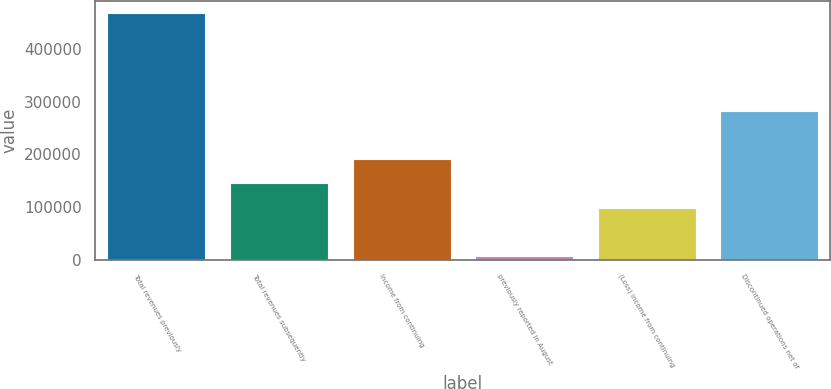Convert chart. <chart><loc_0><loc_0><loc_500><loc_500><bar_chart><fcel>Total revenues previously<fcel>Total revenues subsequently<fcel>Income from continuing<fcel>previously reported in August<fcel>(Loss) income from continuing<fcel>Discontinued operations net of<nl><fcel>467533<fcel>145329<fcel>191358<fcel>7241<fcel>99299.4<fcel>283416<nl></chart> 